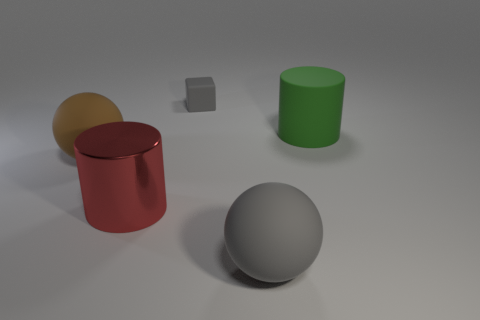How many large rubber objects are the same color as the small cube?
Your answer should be very brief. 1. There is a cylinder that is on the right side of the large gray ball; is its color the same as the tiny rubber block?
Give a very brief answer. No. There is a matte object that is the same color as the tiny rubber block; what size is it?
Your answer should be compact. Large. There is a object that is the same color as the tiny block; what is its material?
Your answer should be very brief. Rubber. Do the cylinder that is on the right side of the big gray object and the ball that is behind the metal object have the same color?
Provide a succinct answer. No. What is the shape of the gray matte object in front of the big rubber thing left of the big thing in front of the big metallic cylinder?
Your response must be concise. Sphere. What is the shape of the large thing that is behind the large red cylinder and in front of the large green matte cylinder?
Make the answer very short. Sphere. How many big brown matte balls are behind the big rubber object in front of the big ball to the left of the big gray matte object?
Offer a very short reply. 1. What size is the matte object that is the same shape as the large red metal object?
Make the answer very short. Large. Are there any other things that have the same size as the brown ball?
Provide a succinct answer. Yes. 